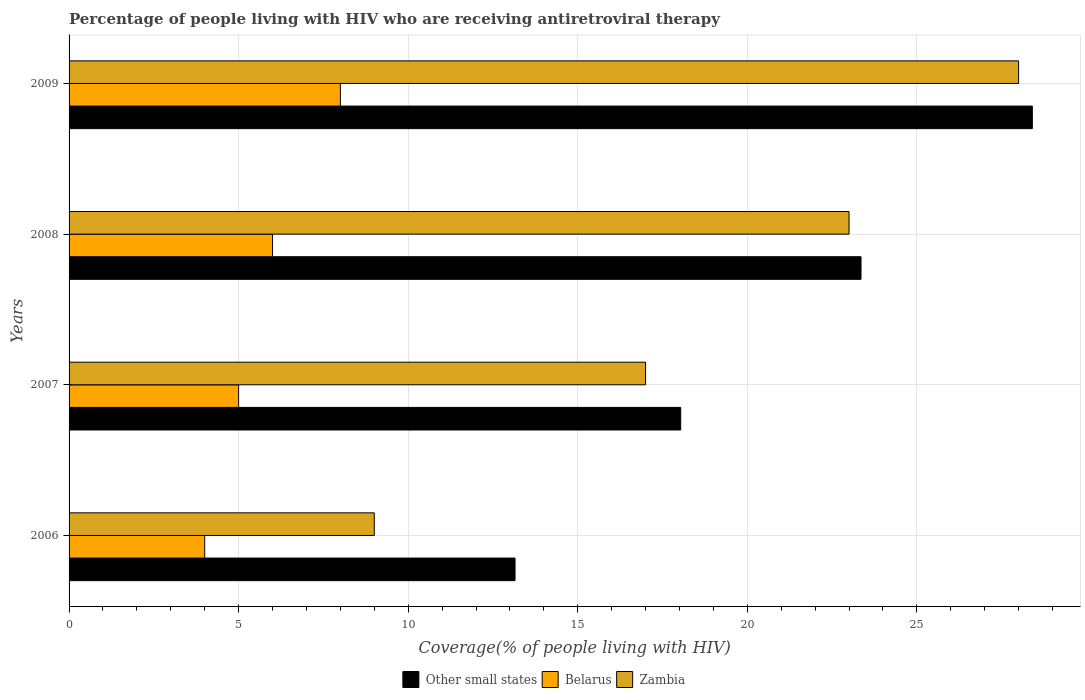How many different coloured bars are there?
Keep it short and to the point. 3. How many bars are there on the 4th tick from the top?
Give a very brief answer. 3. What is the label of the 2nd group of bars from the top?
Your response must be concise. 2008. What is the percentage of the HIV infected people who are receiving antiretroviral therapy in Zambia in 2008?
Keep it short and to the point. 23. Across all years, what is the maximum percentage of the HIV infected people who are receiving antiretroviral therapy in Other small states?
Make the answer very short. 28.4. Across all years, what is the minimum percentage of the HIV infected people who are receiving antiretroviral therapy in Other small states?
Offer a very short reply. 13.15. In which year was the percentage of the HIV infected people who are receiving antiretroviral therapy in Belarus minimum?
Offer a very short reply. 2006. What is the total percentage of the HIV infected people who are receiving antiretroviral therapy in Belarus in the graph?
Your answer should be very brief. 23. What is the difference between the percentage of the HIV infected people who are receiving antiretroviral therapy in Other small states in 2006 and that in 2007?
Offer a terse response. -4.88. What is the difference between the percentage of the HIV infected people who are receiving antiretroviral therapy in Belarus in 2008 and the percentage of the HIV infected people who are receiving antiretroviral therapy in Other small states in 2007?
Provide a succinct answer. -12.04. What is the average percentage of the HIV infected people who are receiving antiretroviral therapy in Belarus per year?
Make the answer very short. 5.75. In the year 2009, what is the difference between the percentage of the HIV infected people who are receiving antiretroviral therapy in Zambia and percentage of the HIV infected people who are receiving antiretroviral therapy in Belarus?
Give a very brief answer. 20. What is the ratio of the percentage of the HIV infected people who are receiving antiretroviral therapy in Zambia in 2007 to that in 2008?
Give a very brief answer. 0.74. Is the difference between the percentage of the HIV infected people who are receiving antiretroviral therapy in Zambia in 2006 and 2009 greater than the difference between the percentage of the HIV infected people who are receiving antiretroviral therapy in Belarus in 2006 and 2009?
Provide a short and direct response. No. What is the difference between the highest and the second highest percentage of the HIV infected people who are receiving antiretroviral therapy in Zambia?
Give a very brief answer. 5. What is the difference between the highest and the lowest percentage of the HIV infected people who are receiving antiretroviral therapy in Belarus?
Your answer should be very brief. 4. What does the 1st bar from the top in 2008 represents?
Give a very brief answer. Zambia. What does the 3rd bar from the bottom in 2007 represents?
Offer a very short reply. Zambia. Is it the case that in every year, the sum of the percentage of the HIV infected people who are receiving antiretroviral therapy in Other small states and percentage of the HIV infected people who are receiving antiretroviral therapy in Belarus is greater than the percentage of the HIV infected people who are receiving antiretroviral therapy in Zambia?
Offer a terse response. Yes. Are all the bars in the graph horizontal?
Ensure brevity in your answer.  Yes. How many years are there in the graph?
Ensure brevity in your answer.  4. What is the difference between two consecutive major ticks on the X-axis?
Offer a terse response. 5. Does the graph contain any zero values?
Ensure brevity in your answer.  No. Does the graph contain grids?
Your response must be concise. Yes. Where does the legend appear in the graph?
Your answer should be very brief. Bottom center. How are the legend labels stacked?
Your answer should be very brief. Horizontal. What is the title of the graph?
Ensure brevity in your answer.  Percentage of people living with HIV who are receiving antiretroviral therapy. What is the label or title of the X-axis?
Your answer should be very brief. Coverage(% of people living with HIV). What is the Coverage(% of people living with HIV) of Other small states in 2006?
Ensure brevity in your answer.  13.15. What is the Coverage(% of people living with HIV) of Zambia in 2006?
Your response must be concise. 9. What is the Coverage(% of people living with HIV) of Other small states in 2007?
Offer a very short reply. 18.04. What is the Coverage(% of people living with HIV) in Zambia in 2007?
Provide a succinct answer. 17. What is the Coverage(% of people living with HIV) in Other small states in 2008?
Give a very brief answer. 23.35. What is the Coverage(% of people living with HIV) of Belarus in 2008?
Your answer should be compact. 6. What is the Coverage(% of people living with HIV) in Zambia in 2008?
Keep it short and to the point. 23. What is the Coverage(% of people living with HIV) of Other small states in 2009?
Offer a very short reply. 28.4. What is the Coverage(% of people living with HIV) of Belarus in 2009?
Your response must be concise. 8. What is the Coverage(% of people living with HIV) of Zambia in 2009?
Your answer should be very brief. 28. Across all years, what is the maximum Coverage(% of people living with HIV) in Other small states?
Your answer should be compact. 28.4. Across all years, what is the minimum Coverage(% of people living with HIV) in Other small states?
Your answer should be compact. 13.15. Across all years, what is the minimum Coverage(% of people living with HIV) of Belarus?
Keep it short and to the point. 4. What is the total Coverage(% of people living with HIV) in Other small states in the graph?
Keep it short and to the point. 82.94. What is the difference between the Coverage(% of people living with HIV) in Other small states in 2006 and that in 2007?
Offer a very short reply. -4.88. What is the difference between the Coverage(% of people living with HIV) of Zambia in 2006 and that in 2007?
Offer a terse response. -8. What is the difference between the Coverage(% of people living with HIV) of Other small states in 2006 and that in 2008?
Your response must be concise. -10.2. What is the difference between the Coverage(% of people living with HIV) in Belarus in 2006 and that in 2008?
Ensure brevity in your answer.  -2. What is the difference between the Coverage(% of people living with HIV) of Other small states in 2006 and that in 2009?
Offer a terse response. -15.25. What is the difference between the Coverage(% of people living with HIV) of Other small states in 2007 and that in 2008?
Keep it short and to the point. -5.32. What is the difference between the Coverage(% of people living with HIV) in Belarus in 2007 and that in 2008?
Keep it short and to the point. -1. What is the difference between the Coverage(% of people living with HIV) in Other small states in 2007 and that in 2009?
Ensure brevity in your answer.  -10.37. What is the difference between the Coverage(% of people living with HIV) in Other small states in 2008 and that in 2009?
Offer a very short reply. -5.05. What is the difference between the Coverage(% of people living with HIV) in Other small states in 2006 and the Coverage(% of people living with HIV) in Belarus in 2007?
Offer a very short reply. 8.15. What is the difference between the Coverage(% of people living with HIV) of Other small states in 2006 and the Coverage(% of people living with HIV) of Zambia in 2007?
Ensure brevity in your answer.  -3.85. What is the difference between the Coverage(% of people living with HIV) of Other small states in 2006 and the Coverage(% of people living with HIV) of Belarus in 2008?
Offer a terse response. 7.15. What is the difference between the Coverage(% of people living with HIV) of Other small states in 2006 and the Coverage(% of people living with HIV) of Zambia in 2008?
Your answer should be compact. -9.85. What is the difference between the Coverage(% of people living with HIV) of Other small states in 2006 and the Coverage(% of people living with HIV) of Belarus in 2009?
Your answer should be compact. 5.15. What is the difference between the Coverage(% of people living with HIV) of Other small states in 2006 and the Coverage(% of people living with HIV) of Zambia in 2009?
Make the answer very short. -14.85. What is the difference between the Coverage(% of people living with HIV) of Belarus in 2006 and the Coverage(% of people living with HIV) of Zambia in 2009?
Your answer should be compact. -24. What is the difference between the Coverage(% of people living with HIV) in Other small states in 2007 and the Coverage(% of people living with HIV) in Belarus in 2008?
Offer a very short reply. 12.04. What is the difference between the Coverage(% of people living with HIV) of Other small states in 2007 and the Coverage(% of people living with HIV) of Zambia in 2008?
Ensure brevity in your answer.  -4.96. What is the difference between the Coverage(% of people living with HIV) in Other small states in 2007 and the Coverage(% of people living with HIV) in Belarus in 2009?
Your answer should be very brief. 10.04. What is the difference between the Coverage(% of people living with HIV) in Other small states in 2007 and the Coverage(% of people living with HIV) in Zambia in 2009?
Provide a succinct answer. -9.96. What is the difference between the Coverage(% of people living with HIV) of Other small states in 2008 and the Coverage(% of people living with HIV) of Belarus in 2009?
Keep it short and to the point. 15.35. What is the difference between the Coverage(% of people living with HIV) in Other small states in 2008 and the Coverage(% of people living with HIV) in Zambia in 2009?
Offer a very short reply. -4.65. What is the difference between the Coverage(% of people living with HIV) of Belarus in 2008 and the Coverage(% of people living with HIV) of Zambia in 2009?
Ensure brevity in your answer.  -22. What is the average Coverage(% of people living with HIV) of Other small states per year?
Ensure brevity in your answer.  20.74. What is the average Coverage(% of people living with HIV) of Belarus per year?
Provide a succinct answer. 5.75. What is the average Coverage(% of people living with HIV) of Zambia per year?
Keep it short and to the point. 19.25. In the year 2006, what is the difference between the Coverage(% of people living with HIV) of Other small states and Coverage(% of people living with HIV) of Belarus?
Make the answer very short. 9.15. In the year 2006, what is the difference between the Coverage(% of people living with HIV) of Other small states and Coverage(% of people living with HIV) of Zambia?
Provide a succinct answer. 4.15. In the year 2007, what is the difference between the Coverage(% of people living with HIV) of Other small states and Coverage(% of people living with HIV) of Belarus?
Provide a short and direct response. 13.04. In the year 2007, what is the difference between the Coverage(% of people living with HIV) of Other small states and Coverage(% of people living with HIV) of Zambia?
Provide a short and direct response. 1.03. In the year 2008, what is the difference between the Coverage(% of people living with HIV) in Other small states and Coverage(% of people living with HIV) in Belarus?
Offer a terse response. 17.35. In the year 2008, what is the difference between the Coverage(% of people living with HIV) of Other small states and Coverage(% of people living with HIV) of Zambia?
Provide a short and direct response. 0.35. In the year 2009, what is the difference between the Coverage(% of people living with HIV) of Other small states and Coverage(% of people living with HIV) of Belarus?
Make the answer very short. 20.4. In the year 2009, what is the difference between the Coverage(% of people living with HIV) in Other small states and Coverage(% of people living with HIV) in Zambia?
Your answer should be compact. 0.4. In the year 2009, what is the difference between the Coverage(% of people living with HIV) of Belarus and Coverage(% of people living with HIV) of Zambia?
Keep it short and to the point. -20. What is the ratio of the Coverage(% of people living with HIV) of Other small states in 2006 to that in 2007?
Provide a succinct answer. 0.73. What is the ratio of the Coverage(% of people living with HIV) of Zambia in 2006 to that in 2007?
Provide a succinct answer. 0.53. What is the ratio of the Coverage(% of people living with HIV) of Other small states in 2006 to that in 2008?
Offer a terse response. 0.56. What is the ratio of the Coverage(% of people living with HIV) of Belarus in 2006 to that in 2008?
Offer a terse response. 0.67. What is the ratio of the Coverage(% of people living with HIV) in Zambia in 2006 to that in 2008?
Provide a short and direct response. 0.39. What is the ratio of the Coverage(% of people living with HIV) in Other small states in 2006 to that in 2009?
Keep it short and to the point. 0.46. What is the ratio of the Coverage(% of people living with HIV) of Belarus in 2006 to that in 2009?
Offer a terse response. 0.5. What is the ratio of the Coverage(% of people living with HIV) of Zambia in 2006 to that in 2009?
Provide a succinct answer. 0.32. What is the ratio of the Coverage(% of people living with HIV) of Other small states in 2007 to that in 2008?
Provide a succinct answer. 0.77. What is the ratio of the Coverage(% of people living with HIV) of Belarus in 2007 to that in 2008?
Your answer should be very brief. 0.83. What is the ratio of the Coverage(% of people living with HIV) in Zambia in 2007 to that in 2008?
Make the answer very short. 0.74. What is the ratio of the Coverage(% of people living with HIV) in Other small states in 2007 to that in 2009?
Provide a short and direct response. 0.63. What is the ratio of the Coverage(% of people living with HIV) of Zambia in 2007 to that in 2009?
Make the answer very short. 0.61. What is the ratio of the Coverage(% of people living with HIV) of Other small states in 2008 to that in 2009?
Make the answer very short. 0.82. What is the ratio of the Coverage(% of people living with HIV) of Belarus in 2008 to that in 2009?
Give a very brief answer. 0.75. What is the ratio of the Coverage(% of people living with HIV) in Zambia in 2008 to that in 2009?
Ensure brevity in your answer.  0.82. What is the difference between the highest and the second highest Coverage(% of people living with HIV) in Other small states?
Ensure brevity in your answer.  5.05. What is the difference between the highest and the second highest Coverage(% of people living with HIV) of Zambia?
Your response must be concise. 5. What is the difference between the highest and the lowest Coverage(% of people living with HIV) of Other small states?
Your answer should be compact. 15.25. 